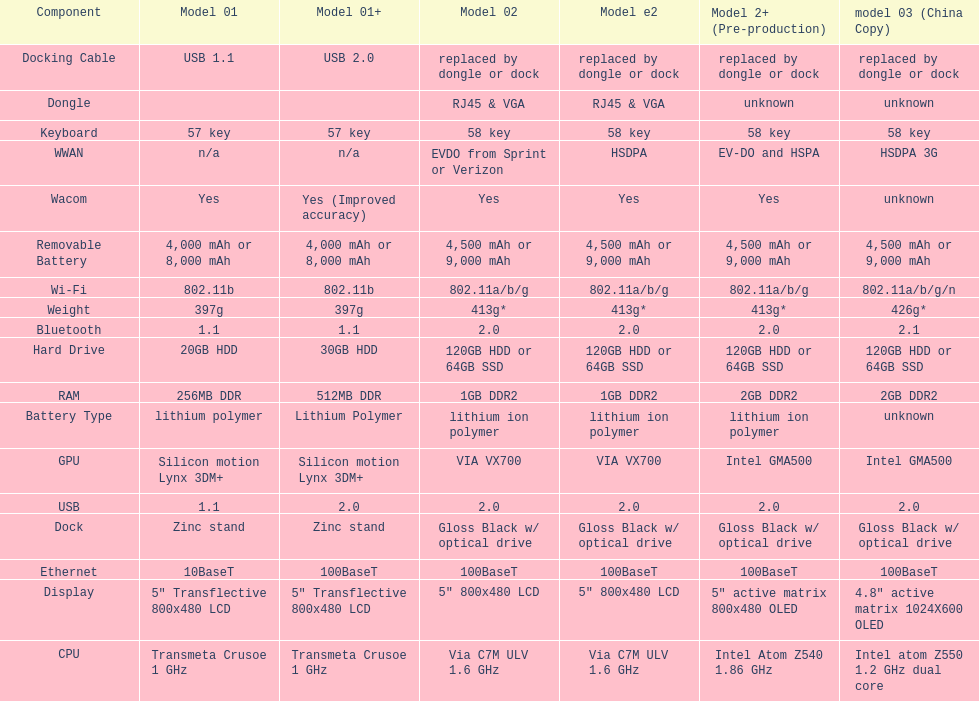What is the average number of models that have usb 2.0? 5. 